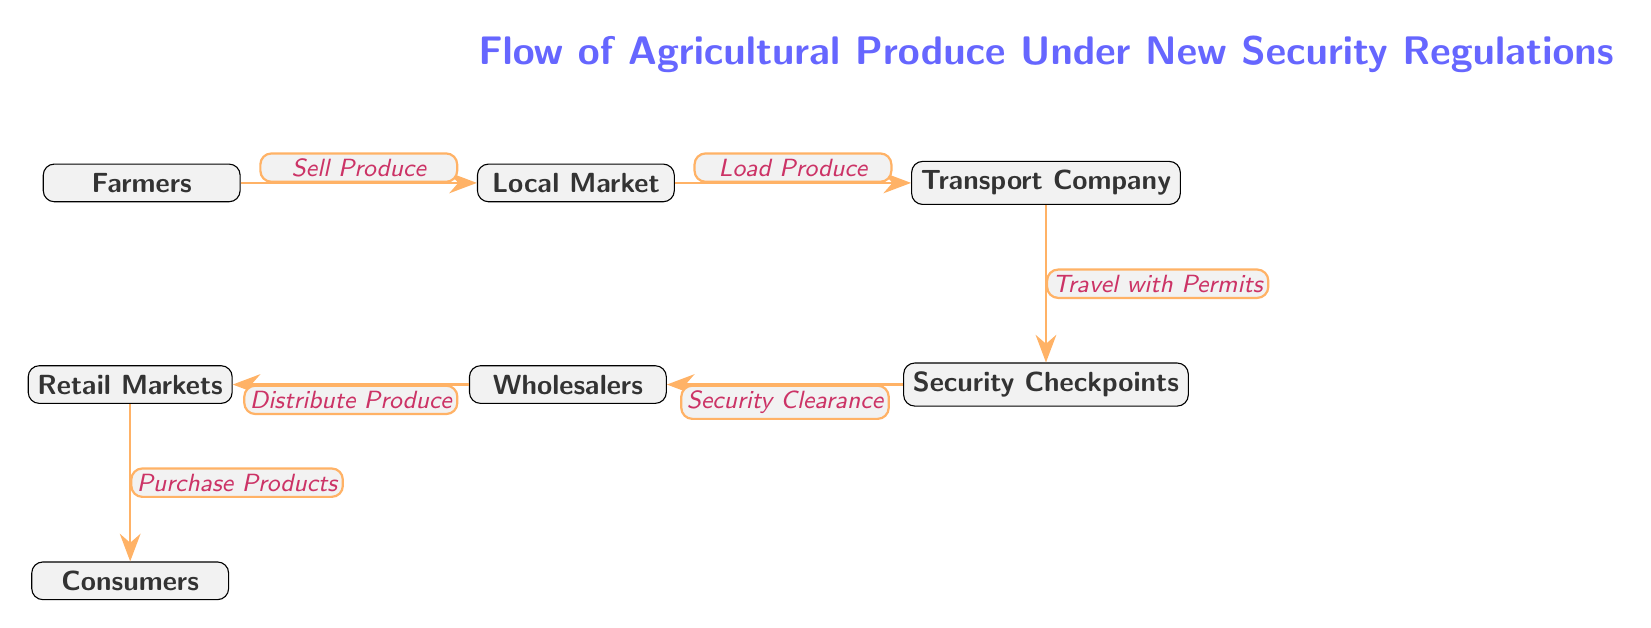What is the starting point of the flow? The starting point of the flow is represented by the node "Farmers", which indicates where the agricultural produce originates.
Answer: Farmers How many nodes are in the diagram? To determine the number of nodes, we can count each distinct element in the flow diagram. The nodes are Farmers, Local Market, Transport Company, Security Checkpoints, Wholesalers, Retail Markets, and Consumers, totaling seven nodes.
Answer: 7 What is the last step before the consumers? According to the flow of the diagram, the last step before reaching the consumers is the node "Retail Markets", which is where the produce is distributed before being purchased by consumers.
Answer: Retail Markets Which node represents the entity that handles transport? The entity that handles transport in this flow is represented by the node "Transport Company", which indicates it is responsible for the transportation of produce.
Answer: Transport Company What is required for the Transport Company to proceed? The Transport Company must have "Permits" in order to travel and transport the produce through the security checkpoints, as indicated in the flow sequence.
Answer: Permits What process occurs at the Security Checkpoints? At the Security Checkpoints, a "Security Clearance" process occurs, which is necessary for the passage of goods through this stage before reaching wholesalers.
Answer: Security Clearance Which node comes immediately after the Local Market? In the sequence shown in the diagram, the node that comes immediately after the Local Market is the "Transport Company," indicating the next phase in the flow of produce.
Answer: Transport Company What action do Wholesalers take with the produce? The action taken by Wholesalers in this flow is to "Distribute Produce," which indicates their role in making the products available to retail markets.
Answer: Distribute Produce What is the key requirement for the produce to move from the Security Checkpoints to Wholesalers? The key requirement for the transfer from Security Checkpoints to Wholesalers is obtaining a "Security Clearance", making sure that the produce complies with regulations.
Answer: Security Clearance 